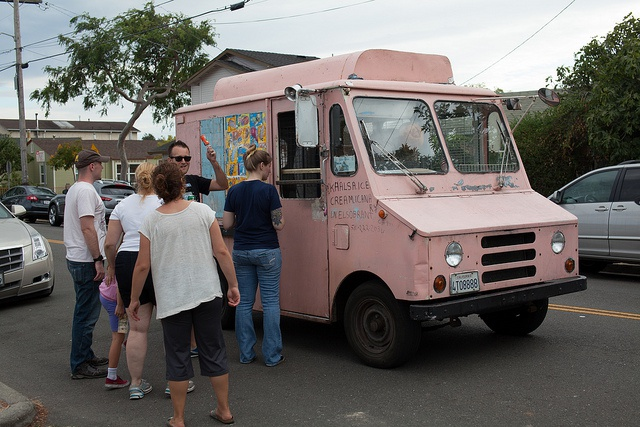Describe the objects in this image and their specific colors. I can see truck in black, darkgray, and gray tones, people in black, darkgray, maroon, and brown tones, people in black, navy, blue, and gray tones, car in black, gray, darkgray, and purple tones, and people in black, darkgray, gray, and lightgray tones in this image. 